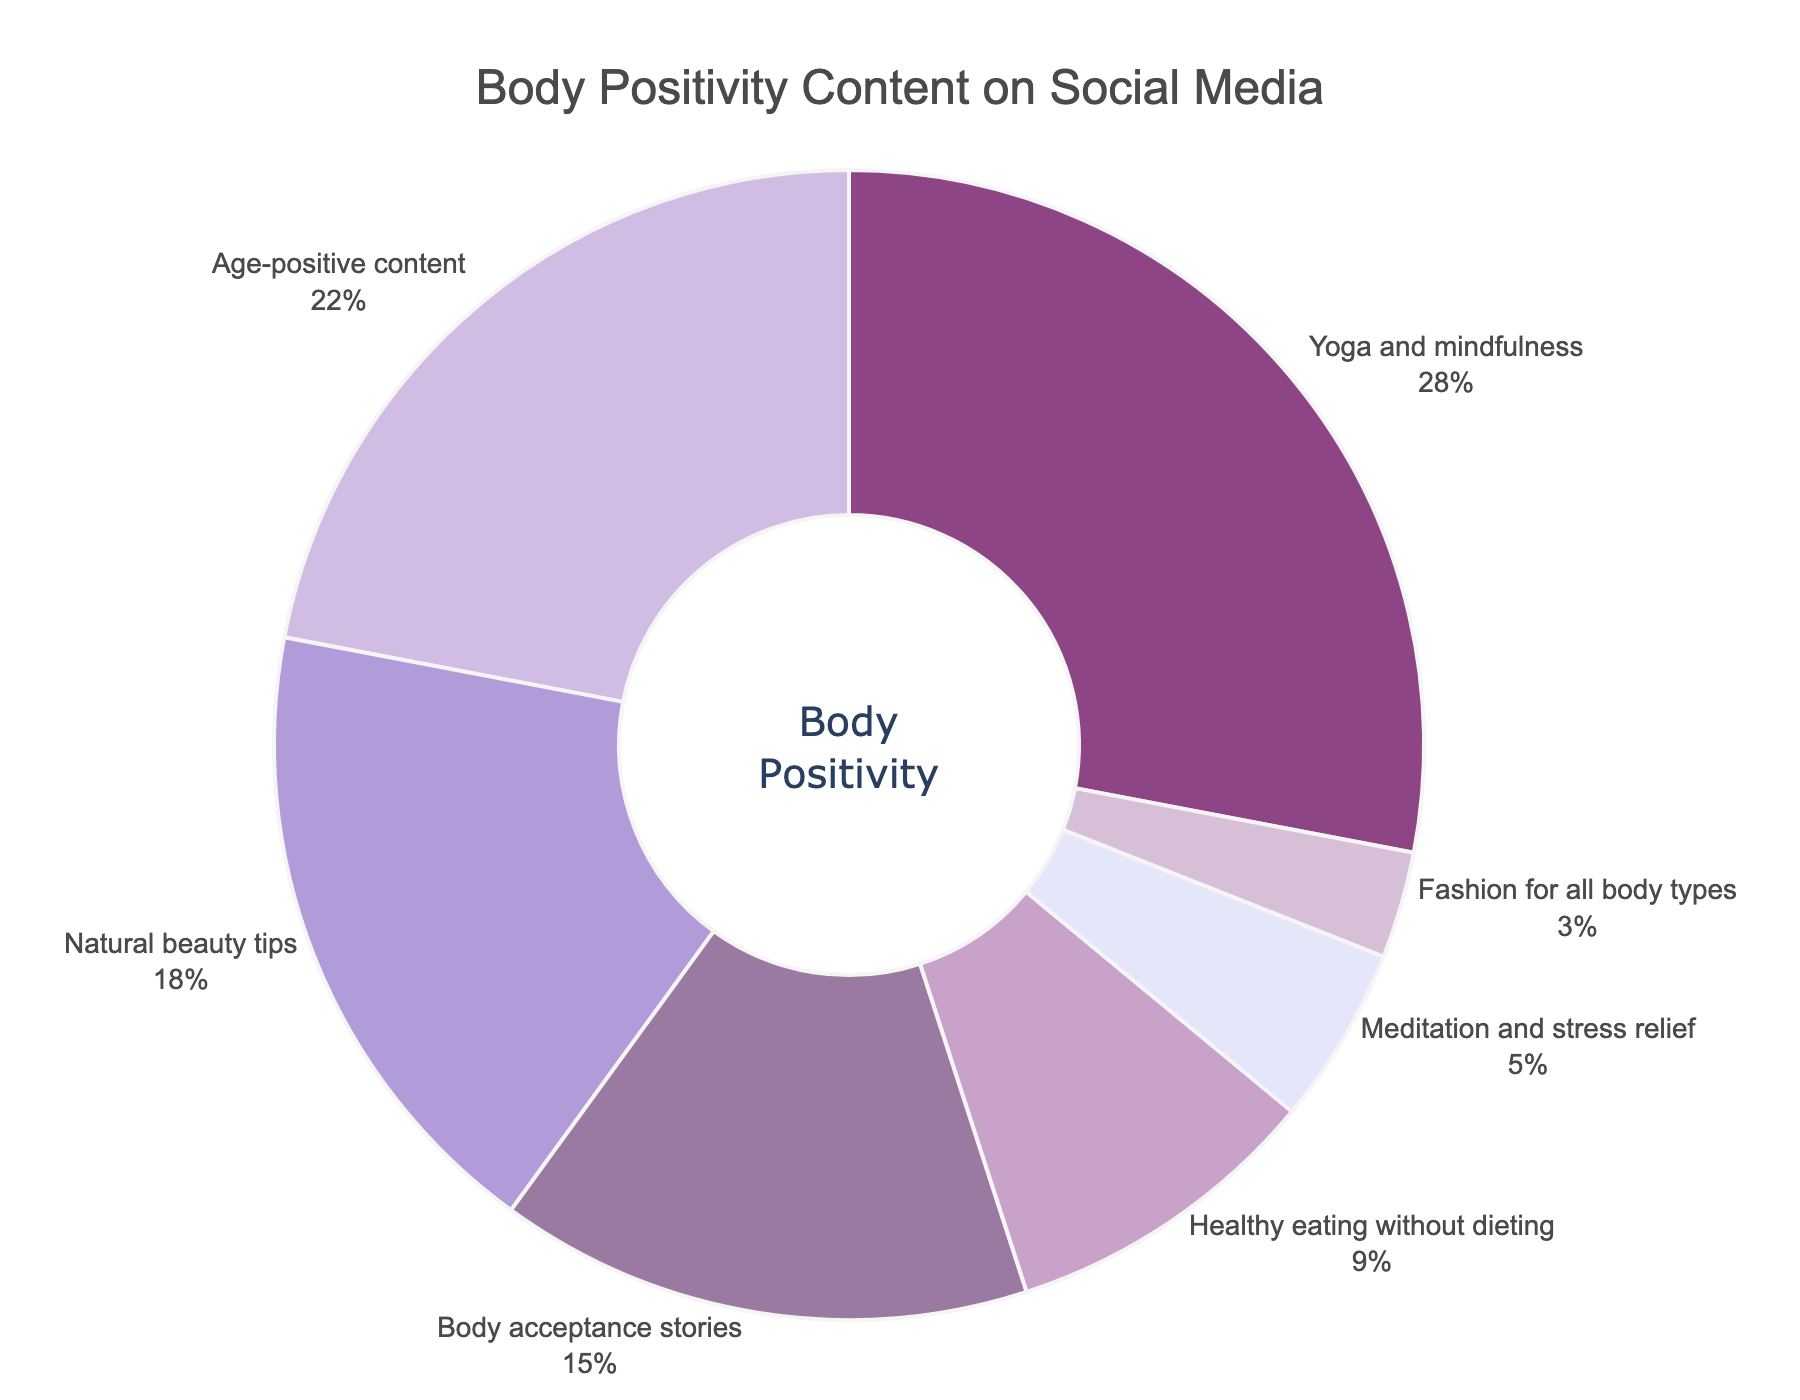What percentage of the content categories is dedicated to Yoga and mindfulness? Yoga and mindfulness takes up 28% of the total percentage, which can be directly seen in the chart.
Answer: 28% How much more percentage is dedicated to Yoga and mindfulness compared to Fashion for all body types? Yoga and mindfulness has 28%, while Fashion for all body types has 3%. The difference is 28% - 3% = 25%.
Answer: 25% Which category has the least representation in the body positivity content? Fashion for all body types has the least representation at 3%, which can be seen in the chart.
Answer: Fashion for all body types What is the combined percentage of content related to stress relief (Meditation and stress relief) and natural well-being (Healthy eating without dieting)? Meditation and stress relief has 5% and Healthy eating without dieting has 9%. Their combined total is 5% + 9% = 14%.
Answer: 14% Compare the percentages of Natural beauty tips and Body acceptance stories. Which category is more prominent? Natural beauty tips have 18%, whereas Body acceptance stories have 15%. Natural beauty tips is more prominent.
Answer: Natural beauty tips What fraction of the total content does Age-positive content represent? Age-positive content represents 22% of the total content. In fraction terms, that's 22/100, which reduces to 11/50.
Answer: 11/50 How does the proportion of Age-positive content compare with the proportion of Healthy eating without dieting? Age-positive content has 22%, whereas Healthy eating without dieting has 9%. Age-positive content is more than twice the proportion of Healthy eating without dieting.
Answer: More than twice What is the total percentage for categories related directly to mental well-being (Yoga and mindfulness, Meditation and stress relief)? Yoga and mindfulness has 28% and Meditation and stress relief has 5%. The total is 28% + 5% = 33%.
Answer: 33% If you sum up the percentages of the top three categories, what do you get? The top three categories are Yoga and mindfulness (28%), Age-positive content (22%), and Natural beauty tips (18%). Their combined total is 28% + 22% + 18% = 68%.
Answer: 68% Which category has a higher percentage: Body acceptance stories or Healthy eating without dieting? Body acceptance stories has 15%, while Healthy eating without dieting has 9%. Body acceptance stories has a higher percentage.
Answer: Body acceptance stories 